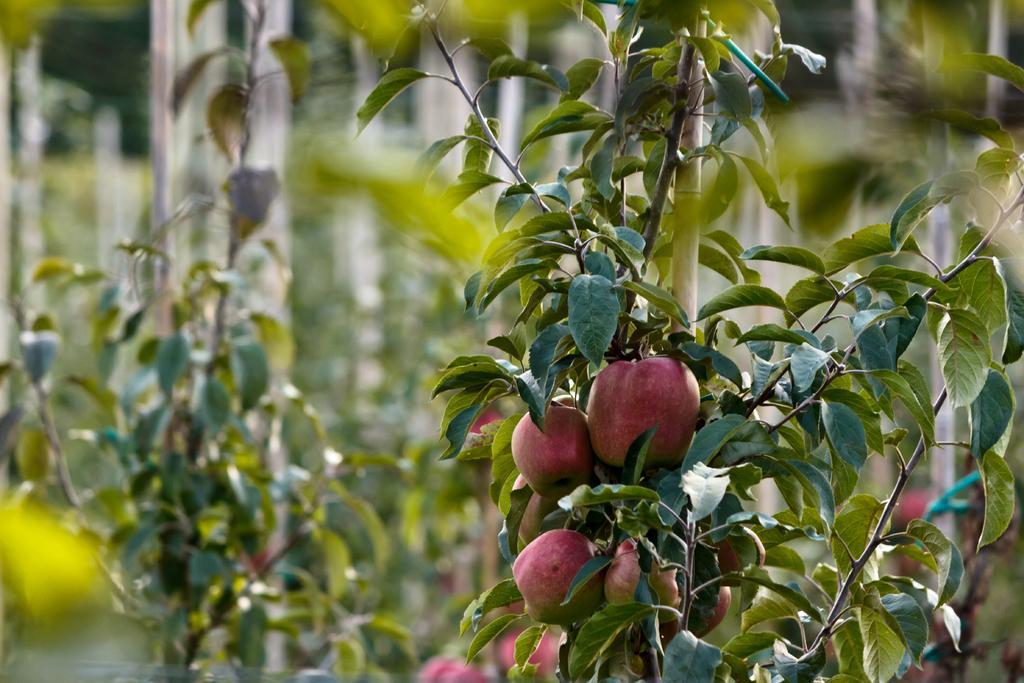Could you give a brief overview of what you see in this image? In this picture I can see there is a plant with fruits and there are few more trees in the backdrop and it is blurred. 